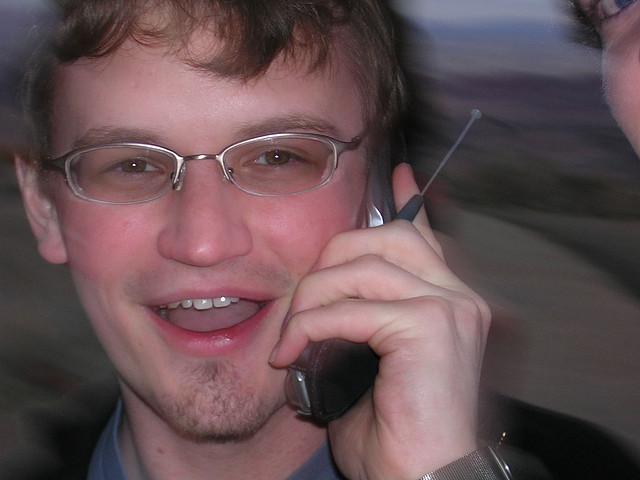Is the man smiling?
Keep it brief. Yes. Is the man excited about his phone conversation?
Give a very brief answer. Yes. What is the man holding?
Keep it brief. Phone. Is his mouth full of toothpaste?
Answer briefly. No. What color is the man's hair?
Short answer required. Brown. How many sunglasses are covering his eyes?
Concise answer only. 0. What color is his eyes?
Write a very short answer. Brown. Is this person an adult?
Keep it brief. Yes. How many phones does the man have?
Give a very brief answer. 1. Why is the man wearing glasses?
Write a very short answer. Yes. 